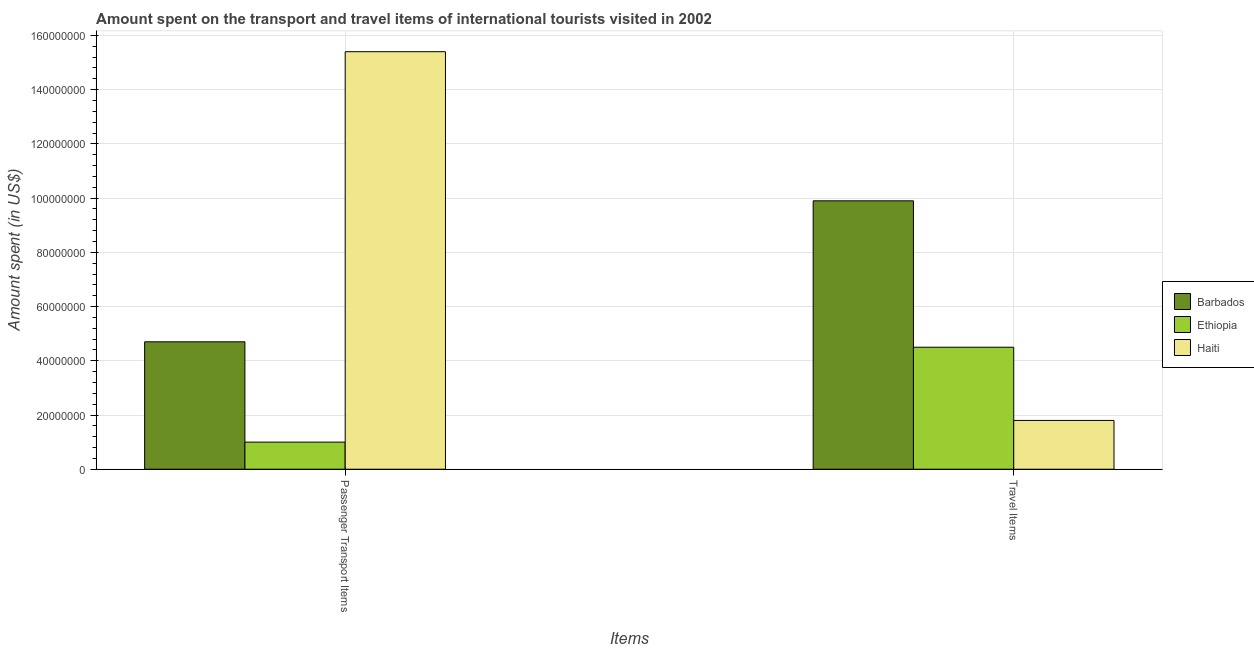How many different coloured bars are there?
Your answer should be compact. 3. Are the number of bars per tick equal to the number of legend labels?
Provide a short and direct response. Yes. Are the number of bars on each tick of the X-axis equal?
Offer a very short reply. Yes. How many bars are there on the 2nd tick from the right?
Keep it short and to the point. 3. What is the label of the 1st group of bars from the left?
Offer a very short reply. Passenger Transport Items. What is the amount spent in travel items in Haiti?
Ensure brevity in your answer.  1.80e+07. Across all countries, what is the maximum amount spent on passenger transport items?
Make the answer very short. 1.54e+08. Across all countries, what is the minimum amount spent on passenger transport items?
Provide a short and direct response. 1.00e+07. In which country was the amount spent in travel items maximum?
Ensure brevity in your answer.  Barbados. In which country was the amount spent in travel items minimum?
Ensure brevity in your answer.  Haiti. What is the total amount spent on passenger transport items in the graph?
Provide a short and direct response. 2.11e+08. What is the difference between the amount spent in travel items in Haiti and that in Barbados?
Give a very brief answer. -8.10e+07. What is the difference between the amount spent in travel items in Barbados and the amount spent on passenger transport items in Ethiopia?
Ensure brevity in your answer.  8.90e+07. What is the average amount spent on passenger transport items per country?
Your response must be concise. 7.03e+07. What is the difference between the amount spent in travel items and amount spent on passenger transport items in Ethiopia?
Offer a terse response. 3.50e+07. Is the amount spent on passenger transport items in Barbados less than that in Haiti?
Provide a succinct answer. Yes. What does the 3rd bar from the left in Passenger Transport Items represents?
Ensure brevity in your answer.  Haiti. What does the 2nd bar from the right in Passenger Transport Items represents?
Offer a terse response. Ethiopia. How many bars are there?
Make the answer very short. 6. What is the difference between two consecutive major ticks on the Y-axis?
Make the answer very short. 2.00e+07. Are the values on the major ticks of Y-axis written in scientific E-notation?
Your response must be concise. No. How many legend labels are there?
Give a very brief answer. 3. What is the title of the graph?
Your response must be concise. Amount spent on the transport and travel items of international tourists visited in 2002. Does "Fragile and conflict affected situations" appear as one of the legend labels in the graph?
Keep it short and to the point. No. What is the label or title of the X-axis?
Your answer should be very brief. Items. What is the label or title of the Y-axis?
Keep it short and to the point. Amount spent (in US$). What is the Amount spent (in US$) of Barbados in Passenger Transport Items?
Give a very brief answer. 4.70e+07. What is the Amount spent (in US$) in Haiti in Passenger Transport Items?
Ensure brevity in your answer.  1.54e+08. What is the Amount spent (in US$) in Barbados in Travel Items?
Provide a succinct answer. 9.90e+07. What is the Amount spent (in US$) of Ethiopia in Travel Items?
Give a very brief answer. 4.50e+07. What is the Amount spent (in US$) of Haiti in Travel Items?
Offer a terse response. 1.80e+07. Across all Items, what is the maximum Amount spent (in US$) of Barbados?
Offer a terse response. 9.90e+07. Across all Items, what is the maximum Amount spent (in US$) in Ethiopia?
Provide a short and direct response. 4.50e+07. Across all Items, what is the maximum Amount spent (in US$) in Haiti?
Offer a terse response. 1.54e+08. Across all Items, what is the minimum Amount spent (in US$) of Barbados?
Keep it short and to the point. 4.70e+07. Across all Items, what is the minimum Amount spent (in US$) in Haiti?
Your response must be concise. 1.80e+07. What is the total Amount spent (in US$) of Barbados in the graph?
Your answer should be compact. 1.46e+08. What is the total Amount spent (in US$) in Ethiopia in the graph?
Give a very brief answer. 5.50e+07. What is the total Amount spent (in US$) of Haiti in the graph?
Give a very brief answer. 1.72e+08. What is the difference between the Amount spent (in US$) in Barbados in Passenger Transport Items and that in Travel Items?
Offer a very short reply. -5.20e+07. What is the difference between the Amount spent (in US$) in Ethiopia in Passenger Transport Items and that in Travel Items?
Provide a succinct answer. -3.50e+07. What is the difference between the Amount spent (in US$) in Haiti in Passenger Transport Items and that in Travel Items?
Offer a terse response. 1.36e+08. What is the difference between the Amount spent (in US$) in Barbados in Passenger Transport Items and the Amount spent (in US$) in Ethiopia in Travel Items?
Provide a short and direct response. 2.00e+06. What is the difference between the Amount spent (in US$) of Barbados in Passenger Transport Items and the Amount spent (in US$) of Haiti in Travel Items?
Your answer should be very brief. 2.90e+07. What is the difference between the Amount spent (in US$) in Ethiopia in Passenger Transport Items and the Amount spent (in US$) in Haiti in Travel Items?
Offer a very short reply. -8.00e+06. What is the average Amount spent (in US$) of Barbados per Items?
Your answer should be compact. 7.30e+07. What is the average Amount spent (in US$) of Ethiopia per Items?
Give a very brief answer. 2.75e+07. What is the average Amount spent (in US$) in Haiti per Items?
Your answer should be very brief. 8.60e+07. What is the difference between the Amount spent (in US$) in Barbados and Amount spent (in US$) in Ethiopia in Passenger Transport Items?
Give a very brief answer. 3.70e+07. What is the difference between the Amount spent (in US$) of Barbados and Amount spent (in US$) of Haiti in Passenger Transport Items?
Keep it short and to the point. -1.07e+08. What is the difference between the Amount spent (in US$) in Ethiopia and Amount spent (in US$) in Haiti in Passenger Transport Items?
Offer a terse response. -1.44e+08. What is the difference between the Amount spent (in US$) in Barbados and Amount spent (in US$) in Ethiopia in Travel Items?
Keep it short and to the point. 5.40e+07. What is the difference between the Amount spent (in US$) of Barbados and Amount spent (in US$) of Haiti in Travel Items?
Offer a very short reply. 8.10e+07. What is the difference between the Amount spent (in US$) of Ethiopia and Amount spent (in US$) of Haiti in Travel Items?
Ensure brevity in your answer.  2.70e+07. What is the ratio of the Amount spent (in US$) of Barbados in Passenger Transport Items to that in Travel Items?
Your answer should be compact. 0.47. What is the ratio of the Amount spent (in US$) of Ethiopia in Passenger Transport Items to that in Travel Items?
Your answer should be very brief. 0.22. What is the ratio of the Amount spent (in US$) of Haiti in Passenger Transport Items to that in Travel Items?
Provide a short and direct response. 8.56. What is the difference between the highest and the second highest Amount spent (in US$) in Barbados?
Your response must be concise. 5.20e+07. What is the difference between the highest and the second highest Amount spent (in US$) in Ethiopia?
Keep it short and to the point. 3.50e+07. What is the difference between the highest and the second highest Amount spent (in US$) of Haiti?
Make the answer very short. 1.36e+08. What is the difference between the highest and the lowest Amount spent (in US$) of Barbados?
Offer a terse response. 5.20e+07. What is the difference between the highest and the lowest Amount spent (in US$) in Ethiopia?
Provide a succinct answer. 3.50e+07. What is the difference between the highest and the lowest Amount spent (in US$) in Haiti?
Make the answer very short. 1.36e+08. 